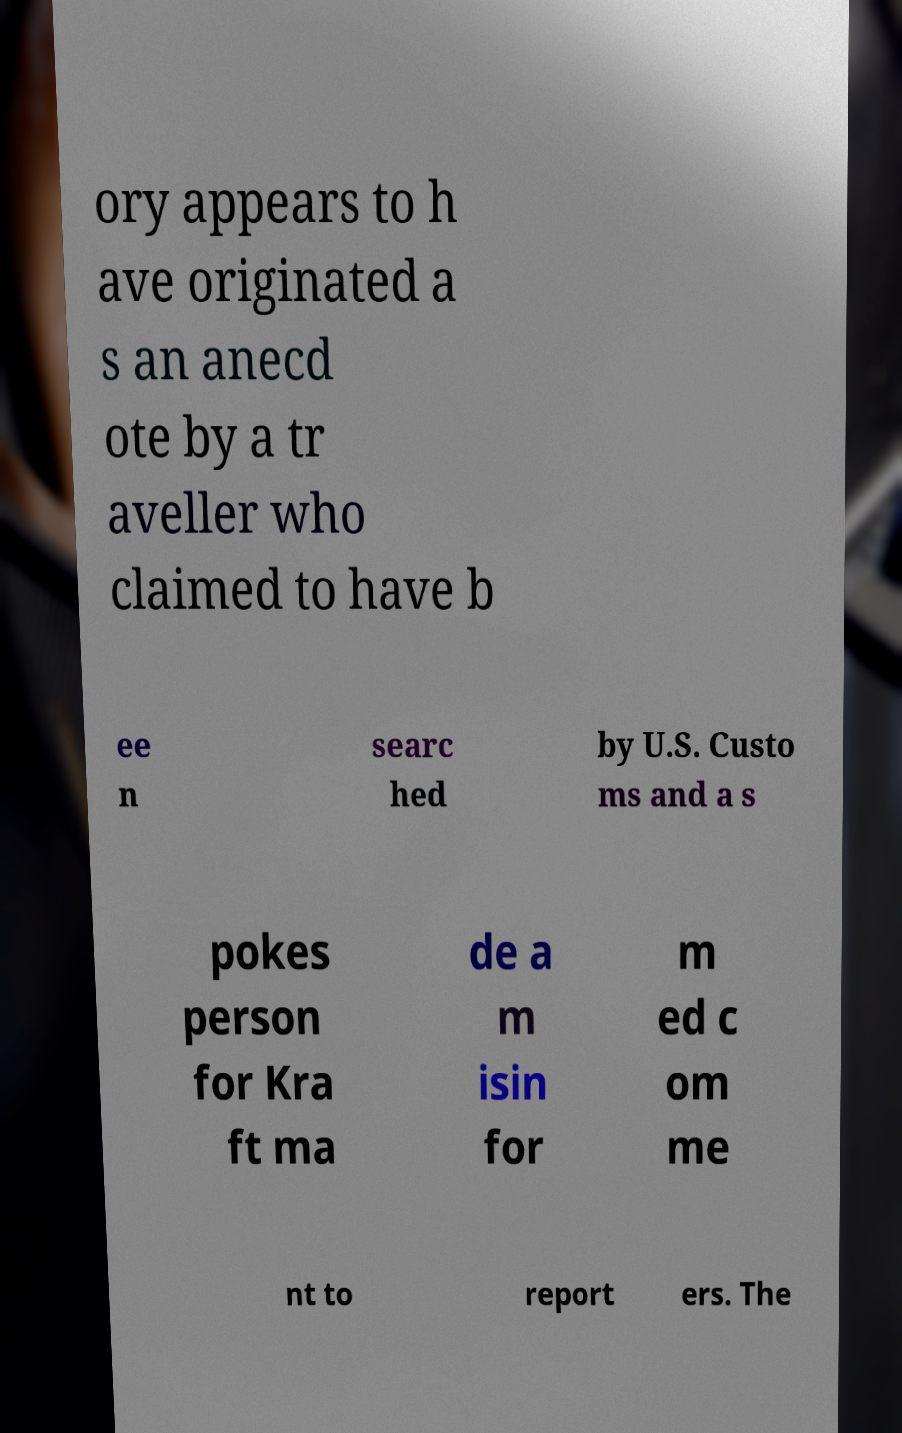Could you extract and type out the text from this image? ory appears to h ave originated a s an anecd ote by a tr aveller who claimed to have b ee n searc hed by U.S. Custo ms and a s pokes person for Kra ft ma de a m isin for m ed c om me nt to report ers. The 